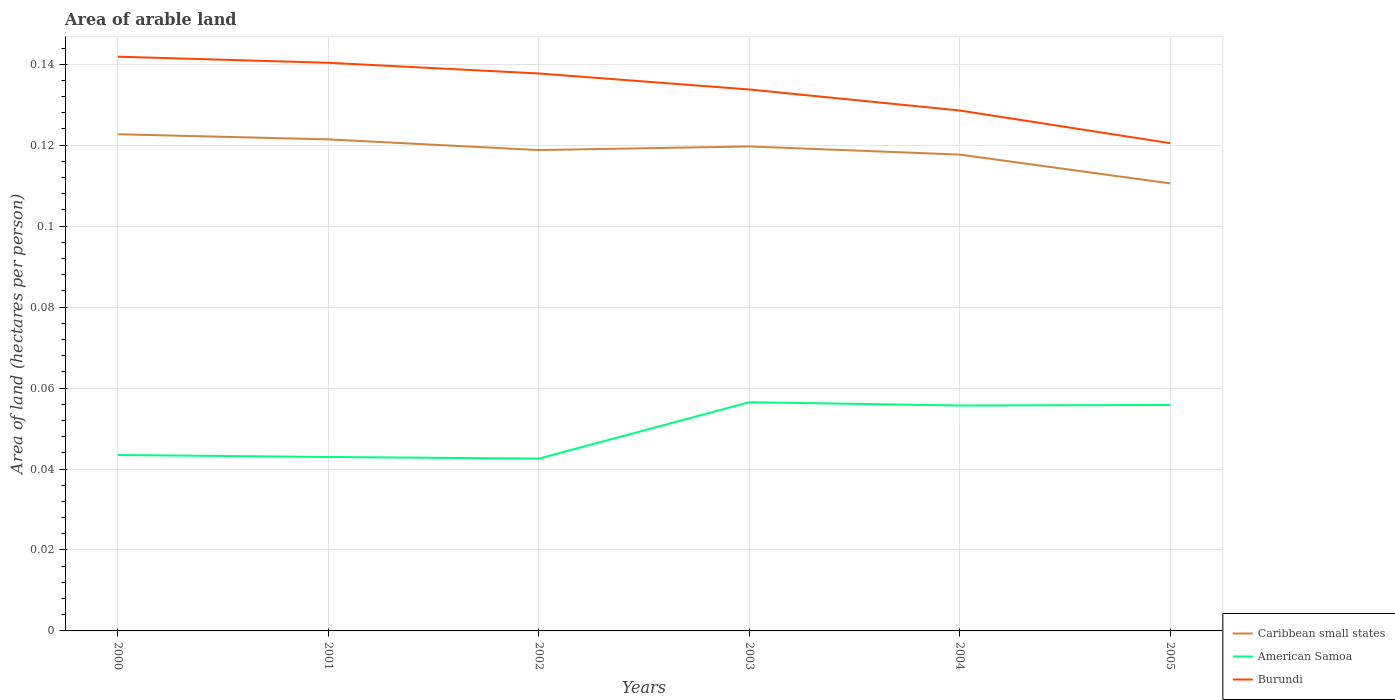How many different coloured lines are there?
Keep it short and to the point. 3. Does the line corresponding to Burundi intersect with the line corresponding to American Samoa?
Provide a succinct answer. No. Across all years, what is the maximum total arable land in Caribbean small states?
Your answer should be compact. 0.11. What is the total total arable land in American Samoa in the graph?
Make the answer very short. 0. What is the difference between the highest and the second highest total arable land in American Samoa?
Offer a terse response. 0.01. What is the difference between the highest and the lowest total arable land in Burundi?
Ensure brevity in your answer.  3. How many lines are there?
Keep it short and to the point. 3. How many years are there in the graph?
Make the answer very short. 6. Are the values on the major ticks of Y-axis written in scientific E-notation?
Offer a terse response. No. Does the graph contain any zero values?
Offer a terse response. No. What is the title of the graph?
Give a very brief answer. Area of arable land. What is the label or title of the X-axis?
Keep it short and to the point. Years. What is the label or title of the Y-axis?
Give a very brief answer. Area of land (hectares per person). What is the Area of land (hectares per person) of Caribbean small states in 2000?
Your response must be concise. 0.12. What is the Area of land (hectares per person) in American Samoa in 2000?
Provide a succinct answer. 0.04. What is the Area of land (hectares per person) of Burundi in 2000?
Your response must be concise. 0.14. What is the Area of land (hectares per person) in Caribbean small states in 2001?
Your response must be concise. 0.12. What is the Area of land (hectares per person) in American Samoa in 2001?
Keep it short and to the point. 0.04. What is the Area of land (hectares per person) of Burundi in 2001?
Keep it short and to the point. 0.14. What is the Area of land (hectares per person) of Caribbean small states in 2002?
Provide a short and direct response. 0.12. What is the Area of land (hectares per person) of American Samoa in 2002?
Keep it short and to the point. 0.04. What is the Area of land (hectares per person) in Burundi in 2002?
Offer a terse response. 0.14. What is the Area of land (hectares per person) in Caribbean small states in 2003?
Keep it short and to the point. 0.12. What is the Area of land (hectares per person) in American Samoa in 2003?
Offer a very short reply. 0.06. What is the Area of land (hectares per person) of Burundi in 2003?
Offer a terse response. 0.13. What is the Area of land (hectares per person) of Caribbean small states in 2004?
Offer a terse response. 0.12. What is the Area of land (hectares per person) of American Samoa in 2004?
Keep it short and to the point. 0.06. What is the Area of land (hectares per person) in Burundi in 2004?
Provide a succinct answer. 0.13. What is the Area of land (hectares per person) in Caribbean small states in 2005?
Provide a succinct answer. 0.11. What is the Area of land (hectares per person) of American Samoa in 2005?
Give a very brief answer. 0.06. What is the Area of land (hectares per person) in Burundi in 2005?
Give a very brief answer. 0.12. Across all years, what is the maximum Area of land (hectares per person) of Caribbean small states?
Provide a short and direct response. 0.12. Across all years, what is the maximum Area of land (hectares per person) in American Samoa?
Give a very brief answer. 0.06. Across all years, what is the maximum Area of land (hectares per person) of Burundi?
Provide a succinct answer. 0.14. Across all years, what is the minimum Area of land (hectares per person) of Caribbean small states?
Your answer should be very brief. 0.11. Across all years, what is the minimum Area of land (hectares per person) in American Samoa?
Keep it short and to the point. 0.04. Across all years, what is the minimum Area of land (hectares per person) of Burundi?
Your response must be concise. 0.12. What is the total Area of land (hectares per person) in Caribbean small states in the graph?
Make the answer very short. 0.71. What is the total Area of land (hectares per person) in American Samoa in the graph?
Make the answer very short. 0.3. What is the total Area of land (hectares per person) in Burundi in the graph?
Make the answer very short. 0.8. What is the difference between the Area of land (hectares per person) in Caribbean small states in 2000 and that in 2001?
Ensure brevity in your answer.  0. What is the difference between the Area of land (hectares per person) in American Samoa in 2000 and that in 2001?
Provide a succinct answer. 0. What is the difference between the Area of land (hectares per person) of Burundi in 2000 and that in 2001?
Make the answer very short. 0. What is the difference between the Area of land (hectares per person) of Caribbean small states in 2000 and that in 2002?
Offer a very short reply. 0. What is the difference between the Area of land (hectares per person) of American Samoa in 2000 and that in 2002?
Offer a very short reply. 0. What is the difference between the Area of land (hectares per person) of Burundi in 2000 and that in 2002?
Keep it short and to the point. 0. What is the difference between the Area of land (hectares per person) of Caribbean small states in 2000 and that in 2003?
Make the answer very short. 0. What is the difference between the Area of land (hectares per person) of American Samoa in 2000 and that in 2003?
Your answer should be compact. -0.01. What is the difference between the Area of land (hectares per person) in Burundi in 2000 and that in 2003?
Make the answer very short. 0.01. What is the difference between the Area of land (hectares per person) of Caribbean small states in 2000 and that in 2004?
Ensure brevity in your answer.  0.01. What is the difference between the Area of land (hectares per person) in American Samoa in 2000 and that in 2004?
Give a very brief answer. -0.01. What is the difference between the Area of land (hectares per person) in Burundi in 2000 and that in 2004?
Your response must be concise. 0.01. What is the difference between the Area of land (hectares per person) in Caribbean small states in 2000 and that in 2005?
Provide a succinct answer. 0.01. What is the difference between the Area of land (hectares per person) in American Samoa in 2000 and that in 2005?
Give a very brief answer. -0.01. What is the difference between the Area of land (hectares per person) in Burundi in 2000 and that in 2005?
Make the answer very short. 0.02. What is the difference between the Area of land (hectares per person) in Caribbean small states in 2001 and that in 2002?
Keep it short and to the point. 0. What is the difference between the Area of land (hectares per person) of American Samoa in 2001 and that in 2002?
Give a very brief answer. 0. What is the difference between the Area of land (hectares per person) of Burundi in 2001 and that in 2002?
Make the answer very short. 0. What is the difference between the Area of land (hectares per person) in Caribbean small states in 2001 and that in 2003?
Offer a very short reply. 0. What is the difference between the Area of land (hectares per person) of American Samoa in 2001 and that in 2003?
Keep it short and to the point. -0.01. What is the difference between the Area of land (hectares per person) in Burundi in 2001 and that in 2003?
Make the answer very short. 0.01. What is the difference between the Area of land (hectares per person) in Caribbean small states in 2001 and that in 2004?
Provide a short and direct response. 0. What is the difference between the Area of land (hectares per person) of American Samoa in 2001 and that in 2004?
Provide a short and direct response. -0.01. What is the difference between the Area of land (hectares per person) in Burundi in 2001 and that in 2004?
Provide a short and direct response. 0.01. What is the difference between the Area of land (hectares per person) of Caribbean small states in 2001 and that in 2005?
Offer a terse response. 0.01. What is the difference between the Area of land (hectares per person) of American Samoa in 2001 and that in 2005?
Offer a terse response. -0.01. What is the difference between the Area of land (hectares per person) of Burundi in 2001 and that in 2005?
Your answer should be very brief. 0.02. What is the difference between the Area of land (hectares per person) of Caribbean small states in 2002 and that in 2003?
Offer a very short reply. -0. What is the difference between the Area of land (hectares per person) of American Samoa in 2002 and that in 2003?
Provide a short and direct response. -0.01. What is the difference between the Area of land (hectares per person) of Burundi in 2002 and that in 2003?
Your answer should be compact. 0. What is the difference between the Area of land (hectares per person) of Caribbean small states in 2002 and that in 2004?
Give a very brief answer. 0. What is the difference between the Area of land (hectares per person) of American Samoa in 2002 and that in 2004?
Make the answer very short. -0.01. What is the difference between the Area of land (hectares per person) in Burundi in 2002 and that in 2004?
Keep it short and to the point. 0.01. What is the difference between the Area of land (hectares per person) in Caribbean small states in 2002 and that in 2005?
Ensure brevity in your answer.  0.01. What is the difference between the Area of land (hectares per person) in American Samoa in 2002 and that in 2005?
Your response must be concise. -0.01. What is the difference between the Area of land (hectares per person) of Burundi in 2002 and that in 2005?
Ensure brevity in your answer.  0.02. What is the difference between the Area of land (hectares per person) of Caribbean small states in 2003 and that in 2004?
Offer a terse response. 0. What is the difference between the Area of land (hectares per person) in American Samoa in 2003 and that in 2004?
Offer a terse response. 0. What is the difference between the Area of land (hectares per person) of Burundi in 2003 and that in 2004?
Provide a succinct answer. 0.01. What is the difference between the Area of land (hectares per person) in Caribbean small states in 2003 and that in 2005?
Your response must be concise. 0.01. What is the difference between the Area of land (hectares per person) in American Samoa in 2003 and that in 2005?
Give a very brief answer. 0. What is the difference between the Area of land (hectares per person) in Burundi in 2003 and that in 2005?
Your answer should be very brief. 0.01. What is the difference between the Area of land (hectares per person) in Caribbean small states in 2004 and that in 2005?
Your response must be concise. 0.01. What is the difference between the Area of land (hectares per person) of American Samoa in 2004 and that in 2005?
Your response must be concise. -0. What is the difference between the Area of land (hectares per person) in Burundi in 2004 and that in 2005?
Your answer should be very brief. 0.01. What is the difference between the Area of land (hectares per person) in Caribbean small states in 2000 and the Area of land (hectares per person) in American Samoa in 2001?
Offer a very short reply. 0.08. What is the difference between the Area of land (hectares per person) in Caribbean small states in 2000 and the Area of land (hectares per person) in Burundi in 2001?
Your answer should be compact. -0.02. What is the difference between the Area of land (hectares per person) of American Samoa in 2000 and the Area of land (hectares per person) of Burundi in 2001?
Provide a succinct answer. -0.1. What is the difference between the Area of land (hectares per person) of Caribbean small states in 2000 and the Area of land (hectares per person) of American Samoa in 2002?
Your answer should be compact. 0.08. What is the difference between the Area of land (hectares per person) of Caribbean small states in 2000 and the Area of land (hectares per person) of Burundi in 2002?
Provide a short and direct response. -0.01. What is the difference between the Area of land (hectares per person) of American Samoa in 2000 and the Area of land (hectares per person) of Burundi in 2002?
Offer a terse response. -0.09. What is the difference between the Area of land (hectares per person) in Caribbean small states in 2000 and the Area of land (hectares per person) in American Samoa in 2003?
Make the answer very short. 0.07. What is the difference between the Area of land (hectares per person) in Caribbean small states in 2000 and the Area of land (hectares per person) in Burundi in 2003?
Make the answer very short. -0.01. What is the difference between the Area of land (hectares per person) of American Samoa in 2000 and the Area of land (hectares per person) of Burundi in 2003?
Provide a succinct answer. -0.09. What is the difference between the Area of land (hectares per person) of Caribbean small states in 2000 and the Area of land (hectares per person) of American Samoa in 2004?
Your response must be concise. 0.07. What is the difference between the Area of land (hectares per person) in Caribbean small states in 2000 and the Area of land (hectares per person) in Burundi in 2004?
Offer a terse response. -0.01. What is the difference between the Area of land (hectares per person) of American Samoa in 2000 and the Area of land (hectares per person) of Burundi in 2004?
Keep it short and to the point. -0.09. What is the difference between the Area of land (hectares per person) in Caribbean small states in 2000 and the Area of land (hectares per person) in American Samoa in 2005?
Your answer should be very brief. 0.07. What is the difference between the Area of land (hectares per person) of Caribbean small states in 2000 and the Area of land (hectares per person) of Burundi in 2005?
Your answer should be very brief. 0. What is the difference between the Area of land (hectares per person) in American Samoa in 2000 and the Area of land (hectares per person) in Burundi in 2005?
Offer a very short reply. -0.08. What is the difference between the Area of land (hectares per person) of Caribbean small states in 2001 and the Area of land (hectares per person) of American Samoa in 2002?
Ensure brevity in your answer.  0.08. What is the difference between the Area of land (hectares per person) in Caribbean small states in 2001 and the Area of land (hectares per person) in Burundi in 2002?
Give a very brief answer. -0.02. What is the difference between the Area of land (hectares per person) of American Samoa in 2001 and the Area of land (hectares per person) of Burundi in 2002?
Your answer should be very brief. -0.09. What is the difference between the Area of land (hectares per person) of Caribbean small states in 2001 and the Area of land (hectares per person) of American Samoa in 2003?
Make the answer very short. 0.06. What is the difference between the Area of land (hectares per person) in Caribbean small states in 2001 and the Area of land (hectares per person) in Burundi in 2003?
Give a very brief answer. -0.01. What is the difference between the Area of land (hectares per person) in American Samoa in 2001 and the Area of land (hectares per person) in Burundi in 2003?
Your response must be concise. -0.09. What is the difference between the Area of land (hectares per person) of Caribbean small states in 2001 and the Area of land (hectares per person) of American Samoa in 2004?
Make the answer very short. 0.07. What is the difference between the Area of land (hectares per person) of Caribbean small states in 2001 and the Area of land (hectares per person) of Burundi in 2004?
Offer a terse response. -0.01. What is the difference between the Area of land (hectares per person) in American Samoa in 2001 and the Area of land (hectares per person) in Burundi in 2004?
Make the answer very short. -0.09. What is the difference between the Area of land (hectares per person) in Caribbean small states in 2001 and the Area of land (hectares per person) in American Samoa in 2005?
Provide a short and direct response. 0.07. What is the difference between the Area of land (hectares per person) in Caribbean small states in 2001 and the Area of land (hectares per person) in Burundi in 2005?
Make the answer very short. 0. What is the difference between the Area of land (hectares per person) of American Samoa in 2001 and the Area of land (hectares per person) of Burundi in 2005?
Provide a succinct answer. -0.08. What is the difference between the Area of land (hectares per person) of Caribbean small states in 2002 and the Area of land (hectares per person) of American Samoa in 2003?
Offer a terse response. 0.06. What is the difference between the Area of land (hectares per person) in Caribbean small states in 2002 and the Area of land (hectares per person) in Burundi in 2003?
Keep it short and to the point. -0.01. What is the difference between the Area of land (hectares per person) of American Samoa in 2002 and the Area of land (hectares per person) of Burundi in 2003?
Provide a short and direct response. -0.09. What is the difference between the Area of land (hectares per person) in Caribbean small states in 2002 and the Area of land (hectares per person) in American Samoa in 2004?
Your answer should be compact. 0.06. What is the difference between the Area of land (hectares per person) of Caribbean small states in 2002 and the Area of land (hectares per person) of Burundi in 2004?
Give a very brief answer. -0.01. What is the difference between the Area of land (hectares per person) of American Samoa in 2002 and the Area of land (hectares per person) of Burundi in 2004?
Keep it short and to the point. -0.09. What is the difference between the Area of land (hectares per person) in Caribbean small states in 2002 and the Area of land (hectares per person) in American Samoa in 2005?
Make the answer very short. 0.06. What is the difference between the Area of land (hectares per person) in Caribbean small states in 2002 and the Area of land (hectares per person) in Burundi in 2005?
Keep it short and to the point. -0. What is the difference between the Area of land (hectares per person) of American Samoa in 2002 and the Area of land (hectares per person) of Burundi in 2005?
Your response must be concise. -0.08. What is the difference between the Area of land (hectares per person) in Caribbean small states in 2003 and the Area of land (hectares per person) in American Samoa in 2004?
Provide a succinct answer. 0.06. What is the difference between the Area of land (hectares per person) of Caribbean small states in 2003 and the Area of land (hectares per person) of Burundi in 2004?
Offer a very short reply. -0.01. What is the difference between the Area of land (hectares per person) of American Samoa in 2003 and the Area of land (hectares per person) of Burundi in 2004?
Make the answer very short. -0.07. What is the difference between the Area of land (hectares per person) of Caribbean small states in 2003 and the Area of land (hectares per person) of American Samoa in 2005?
Keep it short and to the point. 0.06. What is the difference between the Area of land (hectares per person) in Caribbean small states in 2003 and the Area of land (hectares per person) in Burundi in 2005?
Ensure brevity in your answer.  -0. What is the difference between the Area of land (hectares per person) in American Samoa in 2003 and the Area of land (hectares per person) in Burundi in 2005?
Provide a short and direct response. -0.06. What is the difference between the Area of land (hectares per person) in Caribbean small states in 2004 and the Area of land (hectares per person) in American Samoa in 2005?
Your answer should be compact. 0.06. What is the difference between the Area of land (hectares per person) in Caribbean small states in 2004 and the Area of land (hectares per person) in Burundi in 2005?
Provide a succinct answer. -0. What is the difference between the Area of land (hectares per person) in American Samoa in 2004 and the Area of land (hectares per person) in Burundi in 2005?
Offer a very short reply. -0.06. What is the average Area of land (hectares per person) of Caribbean small states per year?
Your answer should be very brief. 0.12. What is the average Area of land (hectares per person) of American Samoa per year?
Provide a succinct answer. 0.05. What is the average Area of land (hectares per person) of Burundi per year?
Provide a short and direct response. 0.13. In the year 2000, what is the difference between the Area of land (hectares per person) of Caribbean small states and Area of land (hectares per person) of American Samoa?
Give a very brief answer. 0.08. In the year 2000, what is the difference between the Area of land (hectares per person) of Caribbean small states and Area of land (hectares per person) of Burundi?
Keep it short and to the point. -0.02. In the year 2000, what is the difference between the Area of land (hectares per person) of American Samoa and Area of land (hectares per person) of Burundi?
Make the answer very short. -0.1. In the year 2001, what is the difference between the Area of land (hectares per person) in Caribbean small states and Area of land (hectares per person) in American Samoa?
Give a very brief answer. 0.08. In the year 2001, what is the difference between the Area of land (hectares per person) in Caribbean small states and Area of land (hectares per person) in Burundi?
Your answer should be very brief. -0.02. In the year 2001, what is the difference between the Area of land (hectares per person) of American Samoa and Area of land (hectares per person) of Burundi?
Offer a very short reply. -0.1. In the year 2002, what is the difference between the Area of land (hectares per person) in Caribbean small states and Area of land (hectares per person) in American Samoa?
Your answer should be very brief. 0.08. In the year 2002, what is the difference between the Area of land (hectares per person) in Caribbean small states and Area of land (hectares per person) in Burundi?
Ensure brevity in your answer.  -0.02. In the year 2002, what is the difference between the Area of land (hectares per person) in American Samoa and Area of land (hectares per person) in Burundi?
Offer a terse response. -0.1. In the year 2003, what is the difference between the Area of land (hectares per person) of Caribbean small states and Area of land (hectares per person) of American Samoa?
Provide a succinct answer. 0.06. In the year 2003, what is the difference between the Area of land (hectares per person) in Caribbean small states and Area of land (hectares per person) in Burundi?
Provide a succinct answer. -0.01. In the year 2003, what is the difference between the Area of land (hectares per person) of American Samoa and Area of land (hectares per person) of Burundi?
Your answer should be very brief. -0.08. In the year 2004, what is the difference between the Area of land (hectares per person) in Caribbean small states and Area of land (hectares per person) in American Samoa?
Your response must be concise. 0.06. In the year 2004, what is the difference between the Area of land (hectares per person) in Caribbean small states and Area of land (hectares per person) in Burundi?
Offer a terse response. -0.01. In the year 2004, what is the difference between the Area of land (hectares per person) in American Samoa and Area of land (hectares per person) in Burundi?
Provide a succinct answer. -0.07. In the year 2005, what is the difference between the Area of land (hectares per person) of Caribbean small states and Area of land (hectares per person) of American Samoa?
Your response must be concise. 0.05. In the year 2005, what is the difference between the Area of land (hectares per person) of Caribbean small states and Area of land (hectares per person) of Burundi?
Your answer should be compact. -0.01. In the year 2005, what is the difference between the Area of land (hectares per person) of American Samoa and Area of land (hectares per person) of Burundi?
Your answer should be compact. -0.06. What is the ratio of the Area of land (hectares per person) in Caribbean small states in 2000 to that in 2001?
Your answer should be very brief. 1.01. What is the ratio of the Area of land (hectares per person) in American Samoa in 2000 to that in 2001?
Give a very brief answer. 1.01. What is the ratio of the Area of land (hectares per person) of Burundi in 2000 to that in 2001?
Make the answer very short. 1.01. What is the ratio of the Area of land (hectares per person) in Caribbean small states in 2000 to that in 2002?
Your answer should be very brief. 1.03. What is the ratio of the Area of land (hectares per person) of Burundi in 2000 to that in 2002?
Offer a terse response. 1.03. What is the ratio of the Area of land (hectares per person) in Caribbean small states in 2000 to that in 2003?
Give a very brief answer. 1.03. What is the ratio of the Area of land (hectares per person) in American Samoa in 2000 to that in 2003?
Your response must be concise. 0.77. What is the ratio of the Area of land (hectares per person) of Burundi in 2000 to that in 2003?
Your response must be concise. 1.06. What is the ratio of the Area of land (hectares per person) in Caribbean small states in 2000 to that in 2004?
Make the answer very short. 1.04. What is the ratio of the Area of land (hectares per person) of American Samoa in 2000 to that in 2004?
Make the answer very short. 0.78. What is the ratio of the Area of land (hectares per person) in Burundi in 2000 to that in 2004?
Offer a very short reply. 1.1. What is the ratio of the Area of land (hectares per person) of Caribbean small states in 2000 to that in 2005?
Make the answer very short. 1.11. What is the ratio of the Area of land (hectares per person) of American Samoa in 2000 to that in 2005?
Offer a very short reply. 0.78. What is the ratio of the Area of land (hectares per person) of Burundi in 2000 to that in 2005?
Your answer should be compact. 1.18. What is the ratio of the Area of land (hectares per person) in Caribbean small states in 2001 to that in 2002?
Give a very brief answer. 1.02. What is the ratio of the Area of land (hectares per person) of American Samoa in 2001 to that in 2002?
Give a very brief answer. 1.01. What is the ratio of the Area of land (hectares per person) in Burundi in 2001 to that in 2002?
Your answer should be very brief. 1.02. What is the ratio of the Area of land (hectares per person) in Caribbean small states in 2001 to that in 2003?
Ensure brevity in your answer.  1.01. What is the ratio of the Area of land (hectares per person) in American Samoa in 2001 to that in 2003?
Offer a very short reply. 0.76. What is the ratio of the Area of land (hectares per person) of Burundi in 2001 to that in 2003?
Your response must be concise. 1.05. What is the ratio of the Area of land (hectares per person) of Caribbean small states in 2001 to that in 2004?
Your answer should be very brief. 1.03. What is the ratio of the Area of land (hectares per person) in American Samoa in 2001 to that in 2004?
Provide a succinct answer. 0.77. What is the ratio of the Area of land (hectares per person) in Burundi in 2001 to that in 2004?
Ensure brevity in your answer.  1.09. What is the ratio of the Area of land (hectares per person) of Caribbean small states in 2001 to that in 2005?
Your response must be concise. 1.1. What is the ratio of the Area of land (hectares per person) in American Samoa in 2001 to that in 2005?
Ensure brevity in your answer.  0.77. What is the ratio of the Area of land (hectares per person) of Burundi in 2001 to that in 2005?
Offer a terse response. 1.16. What is the ratio of the Area of land (hectares per person) of American Samoa in 2002 to that in 2003?
Ensure brevity in your answer.  0.75. What is the ratio of the Area of land (hectares per person) in Burundi in 2002 to that in 2003?
Make the answer very short. 1.03. What is the ratio of the Area of land (hectares per person) of Caribbean small states in 2002 to that in 2004?
Give a very brief answer. 1.01. What is the ratio of the Area of land (hectares per person) of American Samoa in 2002 to that in 2004?
Provide a short and direct response. 0.76. What is the ratio of the Area of land (hectares per person) of Burundi in 2002 to that in 2004?
Your answer should be compact. 1.07. What is the ratio of the Area of land (hectares per person) in Caribbean small states in 2002 to that in 2005?
Provide a succinct answer. 1.07. What is the ratio of the Area of land (hectares per person) of American Samoa in 2002 to that in 2005?
Offer a terse response. 0.76. What is the ratio of the Area of land (hectares per person) of Caribbean small states in 2003 to that in 2004?
Keep it short and to the point. 1.02. What is the ratio of the Area of land (hectares per person) of American Samoa in 2003 to that in 2004?
Provide a succinct answer. 1.01. What is the ratio of the Area of land (hectares per person) of Burundi in 2003 to that in 2004?
Your response must be concise. 1.04. What is the ratio of the Area of land (hectares per person) in Caribbean small states in 2003 to that in 2005?
Offer a very short reply. 1.08. What is the ratio of the Area of land (hectares per person) in American Samoa in 2003 to that in 2005?
Make the answer very short. 1.01. What is the ratio of the Area of land (hectares per person) in Burundi in 2003 to that in 2005?
Provide a succinct answer. 1.11. What is the ratio of the Area of land (hectares per person) in Caribbean small states in 2004 to that in 2005?
Offer a very short reply. 1.06. What is the ratio of the Area of land (hectares per person) of American Samoa in 2004 to that in 2005?
Give a very brief answer. 1. What is the ratio of the Area of land (hectares per person) of Burundi in 2004 to that in 2005?
Provide a short and direct response. 1.07. What is the difference between the highest and the second highest Area of land (hectares per person) in Caribbean small states?
Provide a short and direct response. 0. What is the difference between the highest and the second highest Area of land (hectares per person) in American Samoa?
Keep it short and to the point. 0. What is the difference between the highest and the second highest Area of land (hectares per person) in Burundi?
Ensure brevity in your answer.  0. What is the difference between the highest and the lowest Area of land (hectares per person) in Caribbean small states?
Your answer should be very brief. 0.01. What is the difference between the highest and the lowest Area of land (hectares per person) of American Samoa?
Offer a terse response. 0.01. What is the difference between the highest and the lowest Area of land (hectares per person) in Burundi?
Your response must be concise. 0.02. 